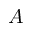<formula> <loc_0><loc_0><loc_500><loc_500>A</formula> 